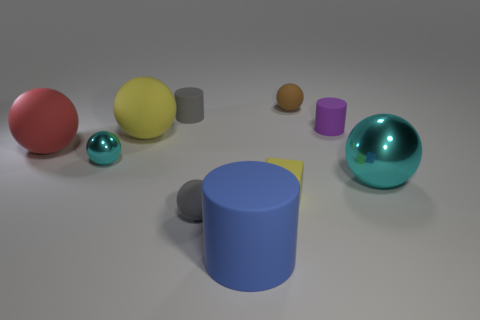What material is the object that is the same color as the block?
Provide a succinct answer. Rubber. There is a metallic sphere that is right of the tiny yellow rubber object; does it have the same color as the small metal thing?
Your response must be concise. Yes. There is a large rubber sphere that is right of the cyan ball left of the big cyan thing; what number of matte balls are in front of it?
Provide a succinct answer. 2. How many tiny rubber cylinders are in front of the small block?
Make the answer very short. 0. What is the color of the other large metal thing that is the same shape as the large red object?
Give a very brief answer. Cyan. The tiny object that is both behind the small purple thing and on the right side of the blue thing is made of what material?
Provide a short and direct response. Rubber. Do the gray matte object that is behind the purple rubber object and the purple rubber object have the same size?
Give a very brief answer. Yes. What material is the tiny block?
Ensure brevity in your answer.  Rubber. There is a cylinder in front of the red rubber ball; what is its color?
Provide a succinct answer. Blue. What number of big objects are either green metallic cylinders or gray cylinders?
Offer a very short reply. 0. 